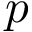Convert formula to latex. <formula><loc_0><loc_0><loc_500><loc_500>p</formula> 